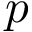Convert formula to latex. <formula><loc_0><loc_0><loc_500><loc_500>p</formula> 